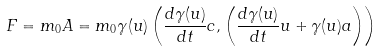<formula> <loc_0><loc_0><loc_500><loc_500>F = m _ { 0 } A = m _ { 0 } \gamma ( u ) \left ( { \frac { d { \gamma } ( u ) } { d t } } c , \left ( { \frac { d { \gamma } ( u ) } { d t } } u + \gamma ( u ) a \right ) \right )</formula> 